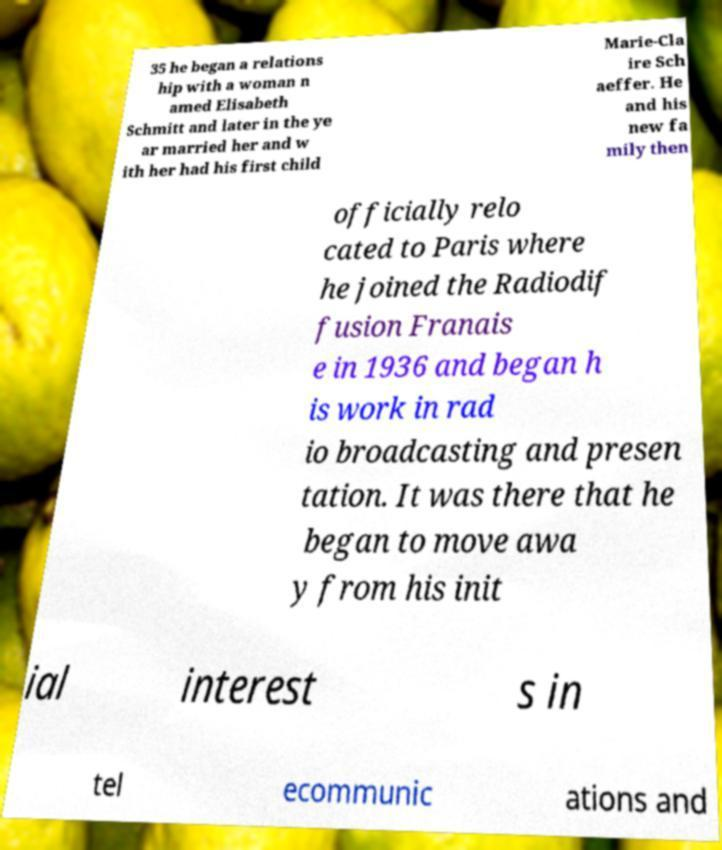For documentation purposes, I need the text within this image transcribed. Could you provide that? 35 he began a relations hip with a woman n amed Elisabeth Schmitt and later in the ye ar married her and w ith her had his first child Marie-Cla ire Sch aeffer. He and his new fa mily then officially relo cated to Paris where he joined the Radiodif fusion Franais e in 1936 and began h is work in rad io broadcasting and presen tation. It was there that he began to move awa y from his init ial interest s in tel ecommunic ations and 